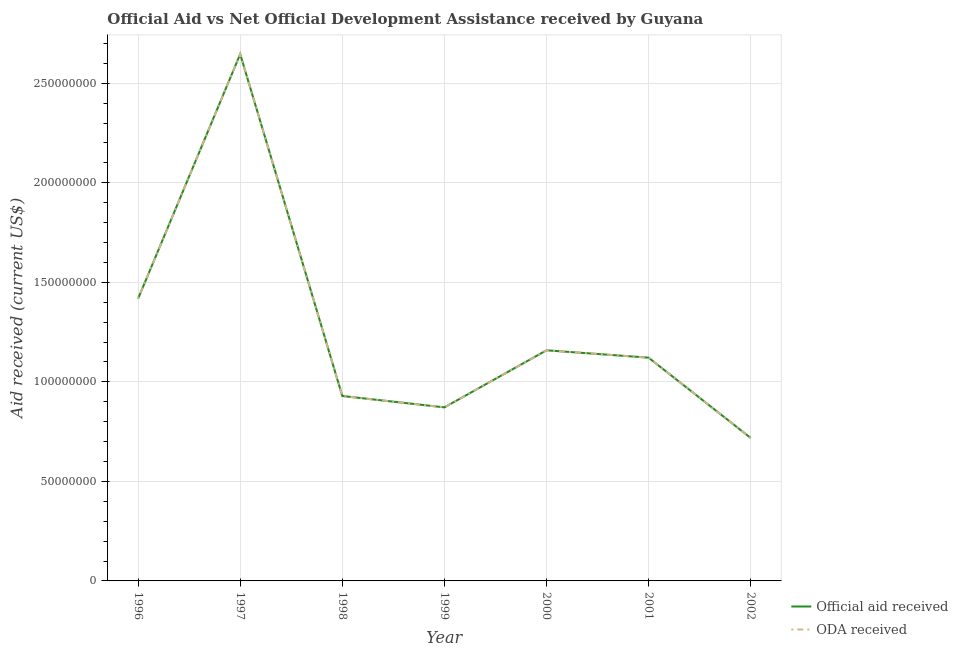How many different coloured lines are there?
Offer a very short reply. 2. Does the line corresponding to oda received intersect with the line corresponding to official aid received?
Offer a terse response. Yes. What is the official aid received in 2000?
Your answer should be very brief. 1.16e+08. Across all years, what is the maximum oda received?
Your answer should be compact. 2.65e+08. Across all years, what is the minimum oda received?
Your answer should be very brief. 7.18e+07. In which year was the oda received maximum?
Provide a short and direct response. 1997. In which year was the oda received minimum?
Your answer should be very brief. 2002. What is the total official aid received in the graph?
Ensure brevity in your answer.  8.86e+08. What is the difference between the official aid received in 1999 and that in 2002?
Provide a short and direct response. 1.53e+07. What is the difference between the official aid received in 1999 and the oda received in 2002?
Give a very brief answer. 1.53e+07. What is the average oda received per year?
Make the answer very short. 1.27e+08. In how many years, is the official aid received greater than 10000000 US$?
Your response must be concise. 7. What is the ratio of the official aid received in 1999 to that in 2002?
Provide a short and direct response. 1.21. Is the official aid received in 2000 less than that in 2001?
Keep it short and to the point. No. What is the difference between the highest and the second highest oda received?
Your answer should be very brief. 1.23e+08. What is the difference between the highest and the lowest official aid received?
Ensure brevity in your answer.  1.93e+08. In how many years, is the oda received greater than the average oda received taken over all years?
Make the answer very short. 2. Does the oda received monotonically increase over the years?
Offer a terse response. No. Is the official aid received strictly greater than the oda received over the years?
Your response must be concise. No. Is the official aid received strictly less than the oda received over the years?
Make the answer very short. No. What is the difference between two consecutive major ticks on the Y-axis?
Offer a very short reply. 5.00e+07. Are the values on the major ticks of Y-axis written in scientific E-notation?
Provide a short and direct response. No. How many legend labels are there?
Keep it short and to the point. 2. How are the legend labels stacked?
Provide a succinct answer. Vertical. What is the title of the graph?
Make the answer very short. Official Aid vs Net Official Development Assistance received by Guyana . Does "Official aid received" appear as one of the legend labels in the graph?
Offer a terse response. Yes. What is the label or title of the Y-axis?
Provide a succinct answer. Aid received (current US$). What is the Aid received (current US$) of Official aid received in 1996?
Your answer should be compact. 1.42e+08. What is the Aid received (current US$) of ODA received in 1996?
Give a very brief answer. 1.42e+08. What is the Aid received (current US$) of Official aid received in 1997?
Keep it short and to the point. 2.65e+08. What is the Aid received (current US$) of ODA received in 1997?
Make the answer very short. 2.65e+08. What is the Aid received (current US$) in Official aid received in 1998?
Make the answer very short. 9.29e+07. What is the Aid received (current US$) of ODA received in 1998?
Your response must be concise. 9.29e+07. What is the Aid received (current US$) of Official aid received in 1999?
Keep it short and to the point. 8.72e+07. What is the Aid received (current US$) in ODA received in 1999?
Ensure brevity in your answer.  8.72e+07. What is the Aid received (current US$) in Official aid received in 2000?
Make the answer very short. 1.16e+08. What is the Aid received (current US$) in ODA received in 2000?
Ensure brevity in your answer.  1.16e+08. What is the Aid received (current US$) of Official aid received in 2001?
Your answer should be compact. 1.12e+08. What is the Aid received (current US$) of ODA received in 2001?
Keep it short and to the point. 1.12e+08. What is the Aid received (current US$) of Official aid received in 2002?
Offer a terse response. 7.18e+07. What is the Aid received (current US$) of ODA received in 2002?
Provide a succinct answer. 7.18e+07. Across all years, what is the maximum Aid received (current US$) of Official aid received?
Ensure brevity in your answer.  2.65e+08. Across all years, what is the maximum Aid received (current US$) of ODA received?
Your answer should be very brief. 2.65e+08. Across all years, what is the minimum Aid received (current US$) in Official aid received?
Your answer should be very brief. 7.18e+07. Across all years, what is the minimum Aid received (current US$) of ODA received?
Give a very brief answer. 7.18e+07. What is the total Aid received (current US$) of Official aid received in the graph?
Provide a succinct answer. 8.86e+08. What is the total Aid received (current US$) in ODA received in the graph?
Keep it short and to the point. 8.86e+08. What is the difference between the Aid received (current US$) of Official aid received in 1996 and that in 1997?
Offer a terse response. -1.23e+08. What is the difference between the Aid received (current US$) in ODA received in 1996 and that in 1997?
Make the answer very short. -1.23e+08. What is the difference between the Aid received (current US$) of Official aid received in 1996 and that in 1998?
Give a very brief answer. 4.89e+07. What is the difference between the Aid received (current US$) of ODA received in 1996 and that in 1998?
Your response must be concise. 4.89e+07. What is the difference between the Aid received (current US$) in Official aid received in 1996 and that in 1999?
Your answer should be very brief. 5.46e+07. What is the difference between the Aid received (current US$) of ODA received in 1996 and that in 1999?
Your answer should be very brief. 5.46e+07. What is the difference between the Aid received (current US$) in Official aid received in 1996 and that in 2000?
Your answer should be compact. 2.60e+07. What is the difference between the Aid received (current US$) of ODA received in 1996 and that in 2000?
Provide a short and direct response. 2.60e+07. What is the difference between the Aid received (current US$) in Official aid received in 1996 and that in 2001?
Make the answer very short. 2.97e+07. What is the difference between the Aid received (current US$) in ODA received in 1996 and that in 2001?
Your response must be concise. 2.97e+07. What is the difference between the Aid received (current US$) of Official aid received in 1996 and that in 2002?
Your answer should be very brief. 7.00e+07. What is the difference between the Aid received (current US$) in ODA received in 1996 and that in 2002?
Offer a terse response. 7.00e+07. What is the difference between the Aid received (current US$) of Official aid received in 1997 and that in 1998?
Your response must be concise. 1.72e+08. What is the difference between the Aid received (current US$) in ODA received in 1997 and that in 1998?
Your answer should be compact. 1.72e+08. What is the difference between the Aid received (current US$) in Official aid received in 1997 and that in 1999?
Give a very brief answer. 1.77e+08. What is the difference between the Aid received (current US$) in ODA received in 1997 and that in 1999?
Offer a terse response. 1.77e+08. What is the difference between the Aid received (current US$) in Official aid received in 1997 and that in 2000?
Keep it short and to the point. 1.49e+08. What is the difference between the Aid received (current US$) of ODA received in 1997 and that in 2000?
Give a very brief answer. 1.49e+08. What is the difference between the Aid received (current US$) of Official aid received in 1997 and that in 2001?
Give a very brief answer. 1.52e+08. What is the difference between the Aid received (current US$) in ODA received in 1997 and that in 2001?
Give a very brief answer. 1.52e+08. What is the difference between the Aid received (current US$) in Official aid received in 1997 and that in 2002?
Your answer should be very brief. 1.93e+08. What is the difference between the Aid received (current US$) of ODA received in 1997 and that in 2002?
Your response must be concise. 1.93e+08. What is the difference between the Aid received (current US$) of Official aid received in 1998 and that in 1999?
Your answer should be very brief. 5.72e+06. What is the difference between the Aid received (current US$) of ODA received in 1998 and that in 1999?
Provide a short and direct response. 5.72e+06. What is the difference between the Aid received (current US$) in Official aid received in 1998 and that in 2000?
Offer a very short reply. -2.30e+07. What is the difference between the Aid received (current US$) in ODA received in 1998 and that in 2000?
Offer a terse response. -2.30e+07. What is the difference between the Aid received (current US$) of Official aid received in 1998 and that in 2001?
Your answer should be compact. -1.92e+07. What is the difference between the Aid received (current US$) in ODA received in 1998 and that in 2001?
Keep it short and to the point. -1.92e+07. What is the difference between the Aid received (current US$) in Official aid received in 1998 and that in 2002?
Make the answer very short. 2.11e+07. What is the difference between the Aid received (current US$) in ODA received in 1998 and that in 2002?
Your answer should be very brief. 2.11e+07. What is the difference between the Aid received (current US$) in Official aid received in 1999 and that in 2000?
Your response must be concise. -2.87e+07. What is the difference between the Aid received (current US$) in ODA received in 1999 and that in 2000?
Offer a terse response. -2.87e+07. What is the difference between the Aid received (current US$) of Official aid received in 1999 and that in 2001?
Ensure brevity in your answer.  -2.50e+07. What is the difference between the Aid received (current US$) of ODA received in 1999 and that in 2001?
Offer a very short reply. -2.50e+07. What is the difference between the Aid received (current US$) in Official aid received in 1999 and that in 2002?
Offer a terse response. 1.53e+07. What is the difference between the Aid received (current US$) of ODA received in 1999 and that in 2002?
Ensure brevity in your answer.  1.53e+07. What is the difference between the Aid received (current US$) of Official aid received in 2000 and that in 2001?
Ensure brevity in your answer.  3.70e+06. What is the difference between the Aid received (current US$) in ODA received in 2000 and that in 2001?
Ensure brevity in your answer.  3.70e+06. What is the difference between the Aid received (current US$) of Official aid received in 2000 and that in 2002?
Give a very brief answer. 4.40e+07. What is the difference between the Aid received (current US$) of ODA received in 2000 and that in 2002?
Keep it short and to the point. 4.40e+07. What is the difference between the Aid received (current US$) of Official aid received in 2001 and that in 2002?
Keep it short and to the point. 4.03e+07. What is the difference between the Aid received (current US$) of ODA received in 2001 and that in 2002?
Provide a succinct answer. 4.03e+07. What is the difference between the Aid received (current US$) in Official aid received in 1996 and the Aid received (current US$) in ODA received in 1997?
Provide a succinct answer. -1.23e+08. What is the difference between the Aid received (current US$) of Official aid received in 1996 and the Aid received (current US$) of ODA received in 1998?
Keep it short and to the point. 4.89e+07. What is the difference between the Aid received (current US$) in Official aid received in 1996 and the Aid received (current US$) in ODA received in 1999?
Your answer should be compact. 5.46e+07. What is the difference between the Aid received (current US$) in Official aid received in 1996 and the Aid received (current US$) in ODA received in 2000?
Offer a very short reply. 2.60e+07. What is the difference between the Aid received (current US$) of Official aid received in 1996 and the Aid received (current US$) of ODA received in 2001?
Your answer should be very brief. 2.97e+07. What is the difference between the Aid received (current US$) of Official aid received in 1996 and the Aid received (current US$) of ODA received in 2002?
Offer a terse response. 7.00e+07. What is the difference between the Aid received (current US$) in Official aid received in 1997 and the Aid received (current US$) in ODA received in 1998?
Offer a terse response. 1.72e+08. What is the difference between the Aid received (current US$) of Official aid received in 1997 and the Aid received (current US$) of ODA received in 1999?
Your answer should be compact. 1.77e+08. What is the difference between the Aid received (current US$) of Official aid received in 1997 and the Aid received (current US$) of ODA received in 2000?
Offer a terse response. 1.49e+08. What is the difference between the Aid received (current US$) of Official aid received in 1997 and the Aid received (current US$) of ODA received in 2001?
Your answer should be compact. 1.52e+08. What is the difference between the Aid received (current US$) in Official aid received in 1997 and the Aid received (current US$) in ODA received in 2002?
Offer a terse response. 1.93e+08. What is the difference between the Aid received (current US$) of Official aid received in 1998 and the Aid received (current US$) of ODA received in 1999?
Keep it short and to the point. 5.72e+06. What is the difference between the Aid received (current US$) in Official aid received in 1998 and the Aid received (current US$) in ODA received in 2000?
Your answer should be very brief. -2.30e+07. What is the difference between the Aid received (current US$) of Official aid received in 1998 and the Aid received (current US$) of ODA received in 2001?
Your answer should be very brief. -1.92e+07. What is the difference between the Aid received (current US$) in Official aid received in 1998 and the Aid received (current US$) in ODA received in 2002?
Provide a short and direct response. 2.11e+07. What is the difference between the Aid received (current US$) of Official aid received in 1999 and the Aid received (current US$) of ODA received in 2000?
Keep it short and to the point. -2.87e+07. What is the difference between the Aid received (current US$) in Official aid received in 1999 and the Aid received (current US$) in ODA received in 2001?
Your response must be concise. -2.50e+07. What is the difference between the Aid received (current US$) of Official aid received in 1999 and the Aid received (current US$) of ODA received in 2002?
Your response must be concise. 1.53e+07. What is the difference between the Aid received (current US$) of Official aid received in 2000 and the Aid received (current US$) of ODA received in 2001?
Provide a succinct answer. 3.70e+06. What is the difference between the Aid received (current US$) in Official aid received in 2000 and the Aid received (current US$) in ODA received in 2002?
Give a very brief answer. 4.40e+07. What is the difference between the Aid received (current US$) of Official aid received in 2001 and the Aid received (current US$) of ODA received in 2002?
Ensure brevity in your answer.  4.03e+07. What is the average Aid received (current US$) in Official aid received per year?
Offer a very short reply. 1.27e+08. What is the average Aid received (current US$) in ODA received per year?
Ensure brevity in your answer.  1.27e+08. In the year 1996, what is the difference between the Aid received (current US$) of Official aid received and Aid received (current US$) of ODA received?
Offer a very short reply. 0. In the year 1998, what is the difference between the Aid received (current US$) in Official aid received and Aid received (current US$) in ODA received?
Your answer should be compact. 0. In the year 2000, what is the difference between the Aid received (current US$) in Official aid received and Aid received (current US$) in ODA received?
Make the answer very short. 0. In the year 2002, what is the difference between the Aid received (current US$) in Official aid received and Aid received (current US$) in ODA received?
Ensure brevity in your answer.  0. What is the ratio of the Aid received (current US$) of Official aid received in 1996 to that in 1997?
Offer a terse response. 0.54. What is the ratio of the Aid received (current US$) of ODA received in 1996 to that in 1997?
Keep it short and to the point. 0.54. What is the ratio of the Aid received (current US$) of Official aid received in 1996 to that in 1998?
Offer a very short reply. 1.53. What is the ratio of the Aid received (current US$) in ODA received in 1996 to that in 1998?
Keep it short and to the point. 1.53. What is the ratio of the Aid received (current US$) of Official aid received in 1996 to that in 1999?
Your answer should be compact. 1.63. What is the ratio of the Aid received (current US$) of ODA received in 1996 to that in 1999?
Give a very brief answer. 1.63. What is the ratio of the Aid received (current US$) in Official aid received in 1996 to that in 2000?
Give a very brief answer. 1.22. What is the ratio of the Aid received (current US$) of ODA received in 1996 to that in 2000?
Ensure brevity in your answer.  1.22. What is the ratio of the Aid received (current US$) of Official aid received in 1996 to that in 2001?
Provide a succinct answer. 1.26. What is the ratio of the Aid received (current US$) of ODA received in 1996 to that in 2001?
Keep it short and to the point. 1.26. What is the ratio of the Aid received (current US$) of Official aid received in 1996 to that in 2002?
Offer a very short reply. 1.97. What is the ratio of the Aid received (current US$) of ODA received in 1996 to that in 2002?
Your answer should be compact. 1.97. What is the ratio of the Aid received (current US$) of Official aid received in 1997 to that in 1998?
Your answer should be very brief. 2.85. What is the ratio of the Aid received (current US$) in ODA received in 1997 to that in 1998?
Your answer should be compact. 2.85. What is the ratio of the Aid received (current US$) of Official aid received in 1997 to that in 1999?
Give a very brief answer. 3.04. What is the ratio of the Aid received (current US$) in ODA received in 1997 to that in 1999?
Offer a very short reply. 3.04. What is the ratio of the Aid received (current US$) of Official aid received in 1997 to that in 2000?
Make the answer very short. 2.28. What is the ratio of the Aid received (current US$) in ODA received in 1997 to that in 2000?
Keep it short and to the point. 2.28. What is the ratio of the Aid received (current US$) in Official aid received in 1997 to that in 2001?
Offer a very short reply. 2.36. What is the ratio of the Aid received (current US$) of ODA received in 1997 to that in 2001?
Your response must be concise. 2.36. What is the ratio of the Aid received (current US$) of Official aid received in 1997 to that in 2002?
Give a very brief answer. 3.68. What is the ratio of the Aid received (current US$) of ODA received in 1997 to that in 2002?
Offer a very short reply. 3.68. What is the ratio of the Aid received (current US$) of Official aid received in 1998 to that in 1999?
Ensure brevity in your answer.  1.07. What is the ratio of the Aid received (current US$) of ODA received in 1998 to that in 1999?
Your answer should be compact. 1.07. What is the ratio of the Aid received (current US$) in Official aid received in 1998 to that in 2000?
Keep it short and to the point. 0.8. What is the ratio of the Aid received (current US$) of ODA received in 1998 to that in 2000?
Provide a short and direct response. 0.8. What is the ratio of the Aid received (current US$) in Official aid received in 1998 to that in 2001?
Your answer should be compact. 0.83. What is the ratio of the Aid received (current US$) of ODA received in 1998 to that in 2001?
Offer a very short reply. 0.83. What is the ratio of the Aid received (current US$) of Official aid received in 1998 to that in 2002?
Make the answer very short. 1.29. What is the ratio of the Aid received (current US$) in ODA received in 1998 to that in 2002?
Provide a short and direct response. 1.29. What is the ratio of the Aid received (current US$) in Official aid received in 1999 to that in 2000?
Provide a short and direct response. 0.75. What is the ratio of the Aid received (current US$) in ODA received in 1999 to that in 2000?
Offer a very short reply. 0.75. What is the ratio of the Aid received (current US$) of Official aid received in 1999 to that in 2001?
Make the answer very short. 0.78. What is the ratio of the Aid received (current US$) of ODA received in 1999 to that in 2001?
Provide a short and direct response. 0.78. What is the ratio of the Aid received (current US$) of Official aid received in 1999 to that in 2002?
Your answer should be compact. 1.21. What is the ratio of the Aid received (current US$) of ODA received in 1999 to that in 2002?
Make the answer very short. 1.21. What is the ratio of the Aid received (current US$) in Official aid received in 2000 to that in 2001?
Keep it short and to the point. 1.03. What is the ratio of the Aid received (current US$) of ODA received in 2000 to that in 2001?
Offer a very short reply. 1.03. What is the ratio of the Aid received (current US$) in Official aid received in 2000 to that in 2002?
Your answer should be very brief. 1.61. What is the ratio of the Aid received (current US$) of ODA received in 2000 to that in 2002?
Your answer should be very brief. 1.61. What is the ratio of the Aid received (current US$) in Official aid received in 2001 to that in 2002?
Your response must be concise. 1.56. What is the ratio of the Aid received (current US$) in ODA received in 2001 to that in 2002?
Make the answer very short. 1.56. What is the difference between the highest and the second highest Aid received (current US$) of Official aid received?
Your answer should be very brief. 1.23e+08. What is the difference between the highest and the second highest Aid received (current US$) in ODA received?
Offer a very short reply. 1.23e+08. What is the difference between the highest and the lowest Aid received (current US$) of Official aid received?
Your answer should be compact. 1.93e+08. What is the difference between the highest and the lowest Aid received (current US$) of ODA received?
Your response must be concise. 1.93e+08. 